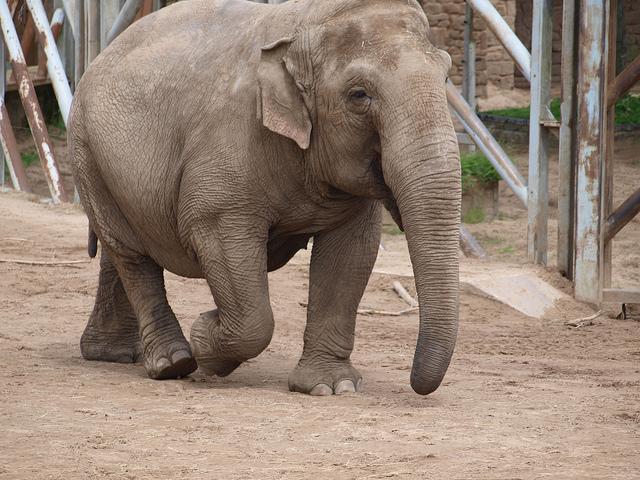What are the elephants eating?
Be succinct. Nothing. What is the fence made out of?
Give a very brief answer. Metal. Is the elephant galloping?
Answer briefly. No. Could an average-sized man lift this animal?
Short answer required. No. Does this animal have a long trunk?
Be succinct. Yes. Is this a baby elephant?
Be succinct. Yes. 